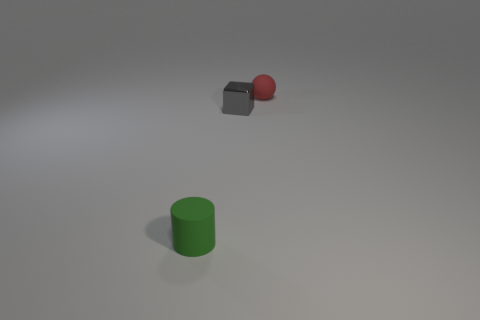Is there any other thing that is made of the same material as the green cylinder?
Your answer should be compact. Yes. There is a matte object that is on the left side of the tiny matte thing behind the tiny matte object that is on the left side of the tiny red matte thing; what is its size?
Offer a terse response. Small. How many other things are the same shape as the small gray object?
Offer a very short reply. 0. Does the small matte object in front of the tiny matte ball have the same color as the rubber thing behind the green object?
Keep it short and to the point. No. What is the color of the rubber cylinder that is the same size as the gray thing?
Your response must be concise. Green. Is there a cube of the same color as the tiny cylinder?
Offer a very short reply. No. There is a object that is to the left of the gray thing; is it the same size as the small block?
Make the answer very short. Yes. Are there an equal number of small red objects to the right of the tiny ball and small green things?
Your answer should be very brief. No. How many things are small rubber things that are on the left side of the small rubber sphere or small yellow matte cylinders?
Ensure brevity in your answer.  1. What shape is the object that is on the left side of the red matte ball and right of the small green rubber object?
Your answer should be very brief. Cube. 